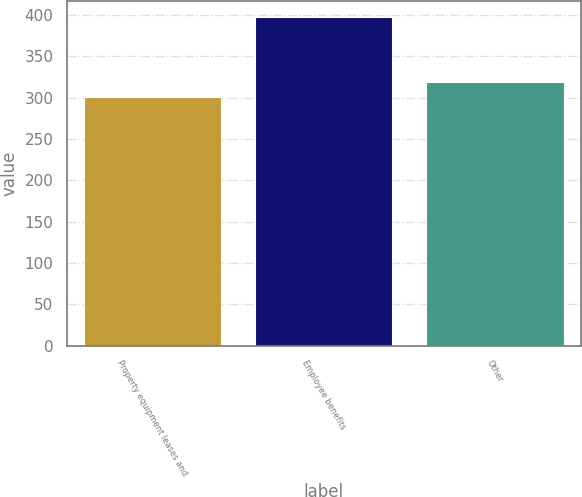Convert chart to OTSL. <chart><loc_0><loc_0><loc_500><loc_500><bar_chart><fcel>Property equipment leases and<fcel>Employee benefits<fcel>Other<nl><fcel>301<fcel>397<fcel>319<nl></chart> 